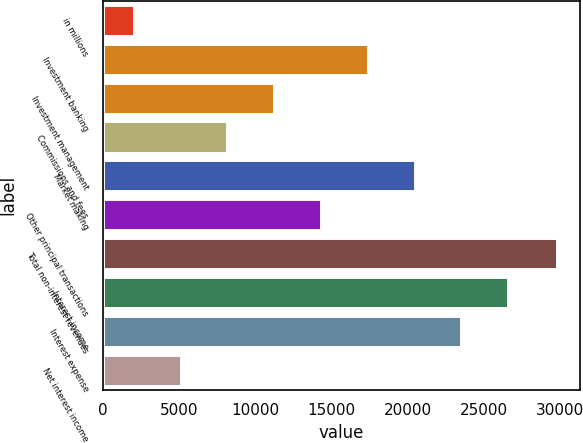<chart> <loc_0><loc_0><loc_500><loc_500><bar_chart><fcel>in millions<fcel>Investment banking<fcel>Investment management<fcel>Commissions and fees<fcel>Market making<fcel>Other principal transactions<fcel>Total non-interest revenues<fcel>Interest income<fcel>Interest expense<fcel>Net interest income<nl><fcel>2017<fcel>17373.5<fcel>11230.9<fcel>8159.6<fcel>20444.8<fcel>14302.2<fcel>29798<fcel>26587.4<fcel>23516.1<fcel>5088.3<nl></chart> 